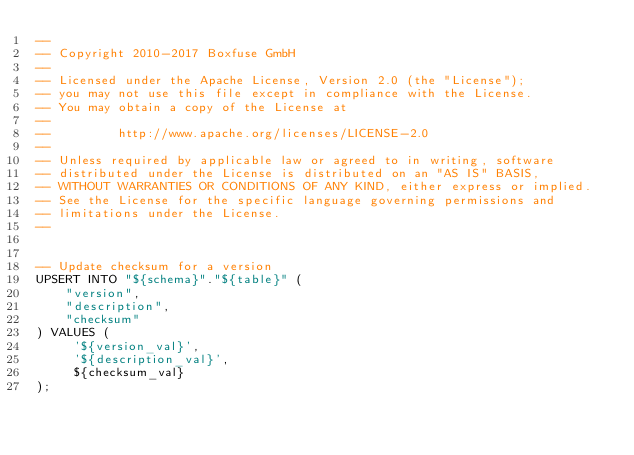Convert code to text. <code><loc_0><loc_0><loc_500><loc_500><_SQL_>--
-- Copyright 2010-2017 Boxfuse GmbH
--
-- Licensed under the Apache License, Version 2.0 (the "License");
-- you may not use this file except in compliance with the License.
-- You may obtain a copy of the License at
--
--         http://www.apache.org/licenses/LICENSE-2.0
--
-- Unless required by applicable law or agreed to in writing, software
-- distributed under the License is distributed on an "AS IS" BASIS,
-- WITHOUT WARRANTIES OR CONDITIONS OF ANY KIND, either express or implied.
-- See the License for the specific language governing permissions and
-- limitations under the License.
--


-- Update checksum for a version
UPSERT INTO "${schema}"."${table}" (
    "version",
    "description",
    "checksum"
) VALUES (
     '${version_val}',
     '${description_val}',
     ${checksum_val}
);</code> 